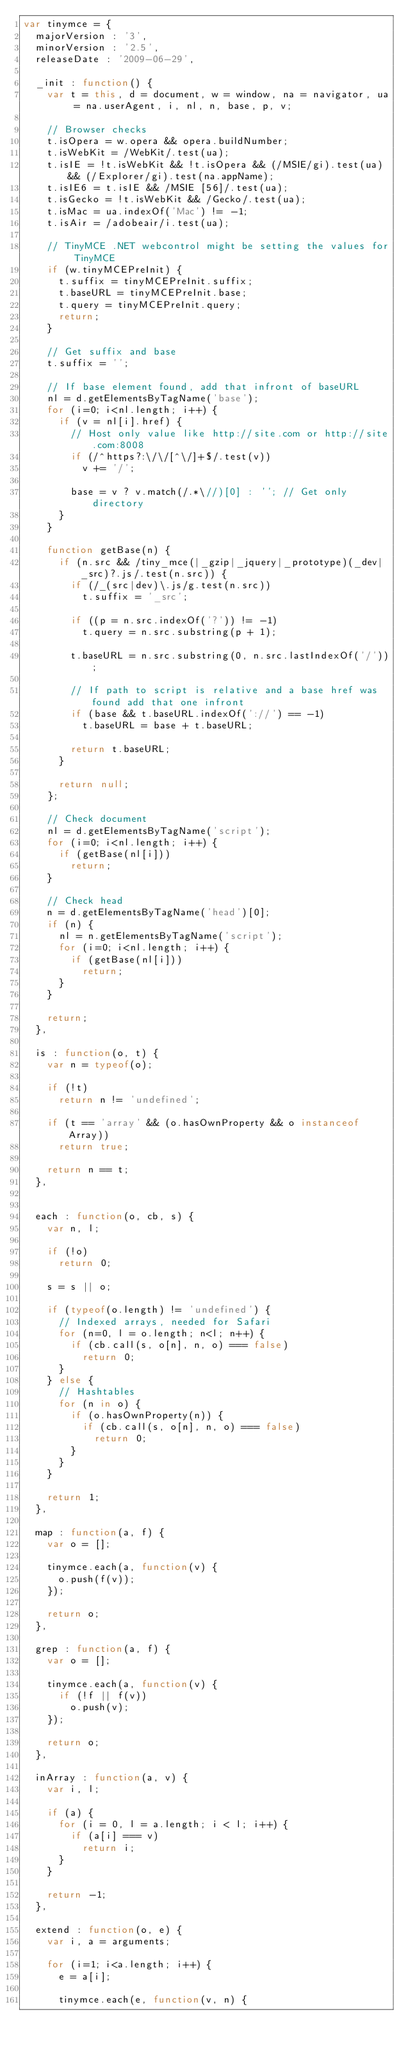Convert code to text. <code><loc_0><loc_0><loc_500><loc_500><_JavaScript_>var tinymce = {
	majorVersion : '3',
	minorVersion : '2.5',
	releaseDate : '2009-06-29',

	_init : function() {
		var t = this, d = document, w = window, na = navigator, ua = na.userAgent, i, nl, n, base, p, v;

		// Browser checks
		t.isOpera = w.opera && opera.buildNumber;
		t.isWebKit = /WebKit/.test(ua);
		t.isIE = !t.isWebKit && !t.isOpera && (/MSIE/gi).test(ua) && (/Explorer/gi).test(na.appName);
		t.isIE6 = t.isIE && /MSIE [56]/.test(ua);
		t.isGecko = !t.isWebKit && /Gecko/.test(ua);
		t.isMac = ua.indexOf('Mac') != -1;
		t.isAir = /adobeair/i.test(ua);

		// TinyMCE .NET webcontrol might be setting the values for TinyMCE
		if (w.tinyMCEPreInit) {
			t.suffix = tinyMCEPreInit.suffix;
			t.baseURL = tinyMCEPreInit.base;
			t.query = tinyMCEPreInit.query;
			return;
		}

		// Get suffix and base
		t.suffix = '';

		// If base element found, add that infront of baseURL
		nl = d.getElementsByTagName('base');
		for (i=0; i<nl.length; i++) {
			if (v = nl[i].href) {
				// Host only value like http://site.com or http://site.com:8008
				if (/^https?:\/\/[^\/]+$/.test(v))
					v += '/';

				base = v ? v.match(/.*\//)[0] : ''; // Get only directory
			}
		}

		function getBase(n) {
			if (n.src && /tiny_mce(|_gzip|_jquery|_prototype)(_dev|_src)?.js/.test(n.src)) {
				if (/_(src|dev)\.js/g.test(n.src))
					t.suffix = '_src';

				if ((p = n.src.indexOf('?')) != -1)
					t.query = n.src.substring(p + 1);

				t.baseURL = n.src.substring(0, n.src.lastIndexOf('/'));

				// If path to script is relative and a base href was found add that one infront
				if (base && t.baseURL.indexOf('://') == -1)
					t.baseURL = base + t.baseURL;

				return t.baseURL;
			}

			return null;
		};

		// Check document
		nl = d.getElementsByTagName('script');
		for (i=0; i<nl.length; i++) {
			if (getBase(nl[i]))
				return;
		}

		// Check head
		n = d.getElementsByTagName('head')[0];
		if (n) {
			nl = n.getElementsByTagName('script');
			for (i=0; i<nl.length; i++) {
				if (getBase(nl[i]))
					return;
			}
		}

		return;
	},

	is : function(o, t) {
		var n = typeof(o);

		if (!t)
			return n != 'undefined';

		if (t == 'array' && (o.hasOwnProperty && o instanceof Array))
			return true;

		return n == t;
	},


	each : function(o, cb, s) {
		var n, l;

		if (!o)
			return 0;

		s = s || o;

		if (typeof(o.length) != 'undefined') {
			// Indexed arrays, needed for Safari
			for (n=0, l = o.length; n<l; n++) {
				if (cb.call(s, o[n], n, o) === false)
					return 0;
			}
		} else {
			// Hashtables
			for (n in o) {
				if (o.hasOwnProperty(n)) {
					if (cb.call(s, o[n], n, o) === false)
						return 0;
				}
			}
		}

		return 1;
	},

	map : function(a, f) {
		var o = [];

		tinymce.each(a, function(v) {
			o.push(f(v));
		});

		return o;
	},

	grep : function(a, f) {
		var o = [];

		tinymce.each(a, function(v) {
			if (!f || f(v))
				o.push(v);
		});

		return o;
	},

	inArray : function(a, v) {
		var i, l;

		if (a) {
			for (i = 0, l = a.length; i < l; i++) {
				if (a[i] === v)
					return i;
			}
		}

		return -1;
	},

	extend : function(o, e) {
		var i, a = arguments;

		for (i=1; i<a.length; i++) {
			e = a[i];

			tinymce.each(e, function(v, n) {</code> 